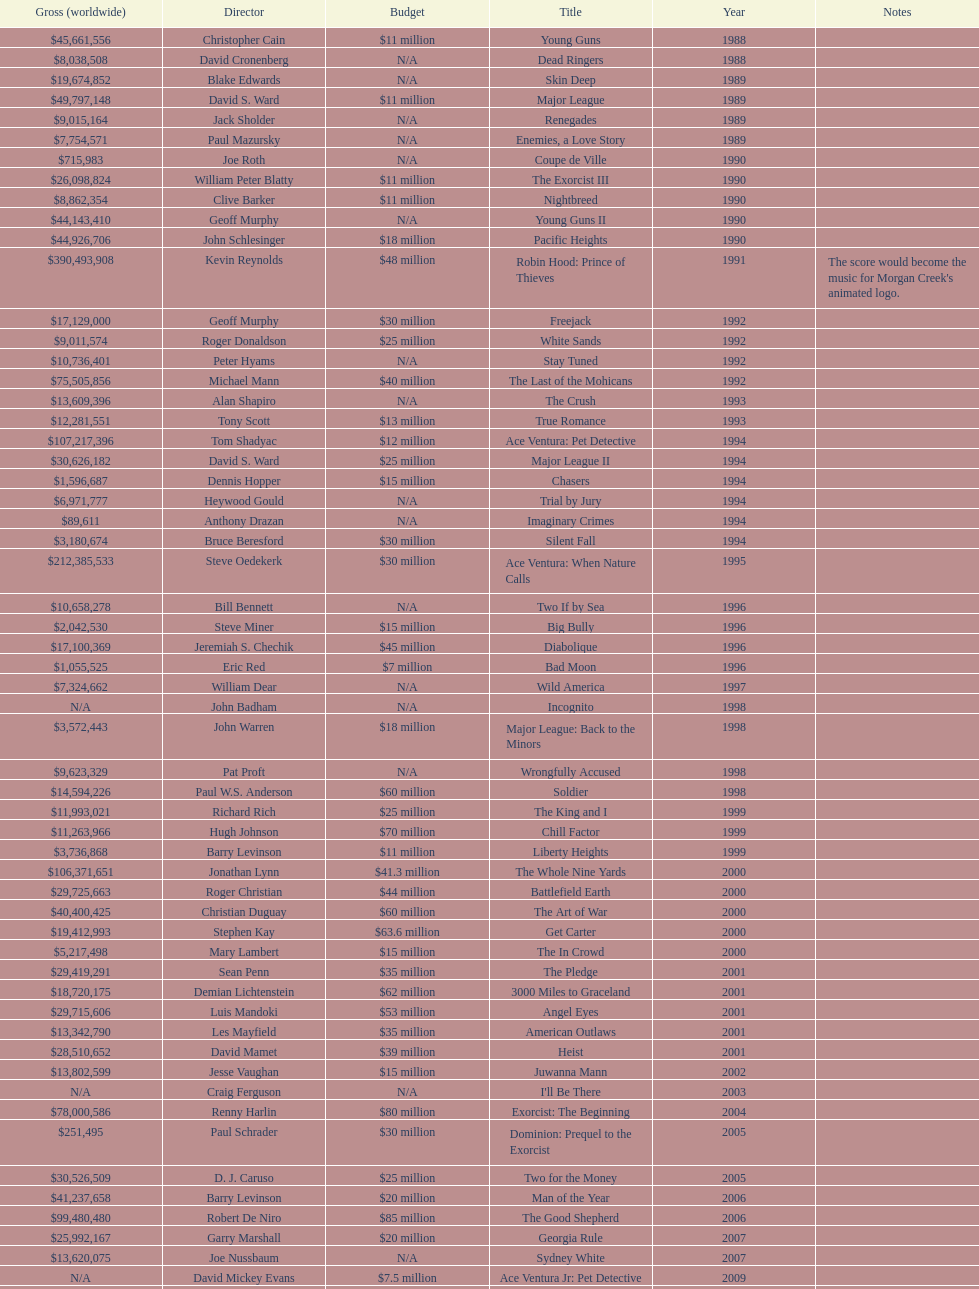Which film had a higher budget, ace ventura: when nature calls, or major league: back to the minors? Ace Ventura: When Nature Calls. 